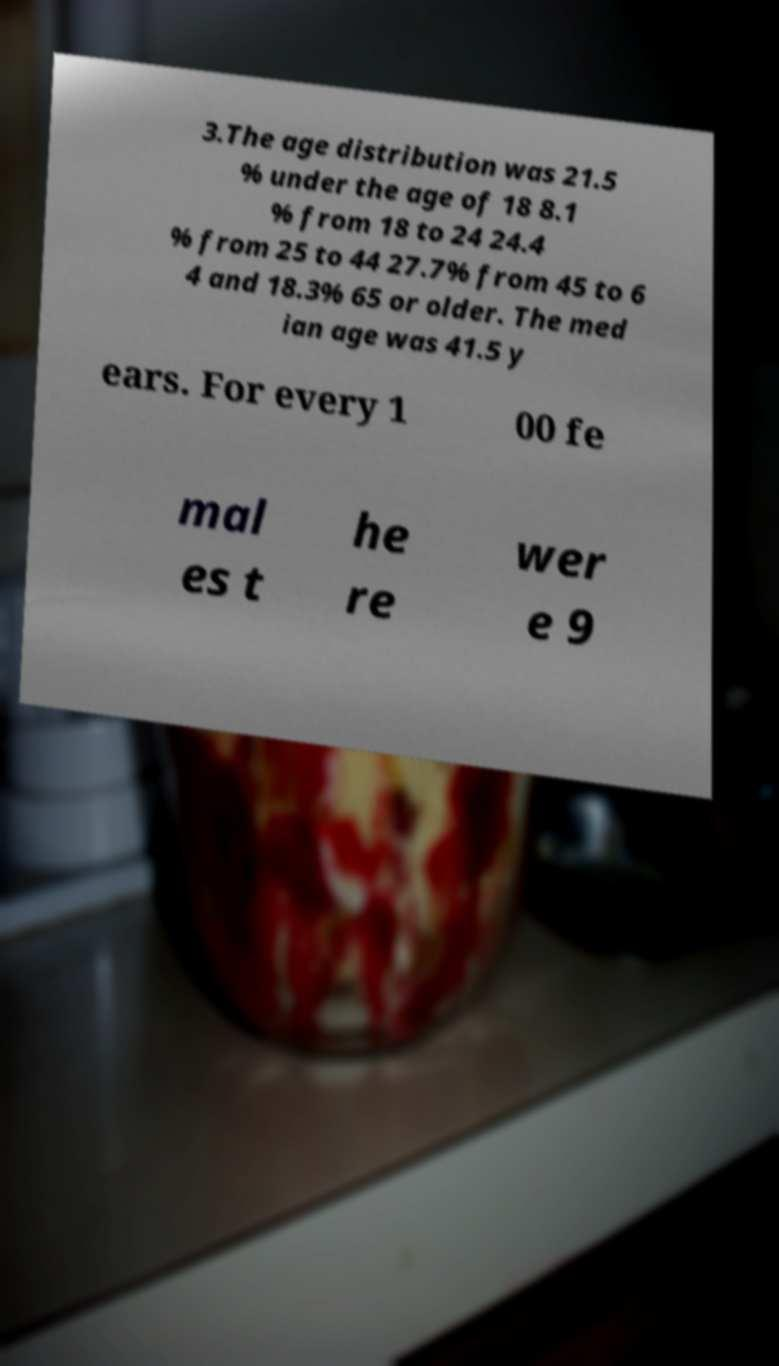Please read and relay the text visible in this image. What does it say? 3.The age distribution was 21.5 % under the age of 18 8.1 % from 18 to 24 24.4 % from 25 to 44 27.7% from 45 to 6 4 and 18.3% 65 or older. The med ian age was 41.5 y ears. For every 1 00 fe mal es t he re wer e 9 